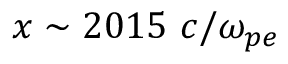<formula> <loc_0><loc_0><loc_500><loc_500>x \sim 2 0 1 5 c / \omega _ { p e }</formula> 